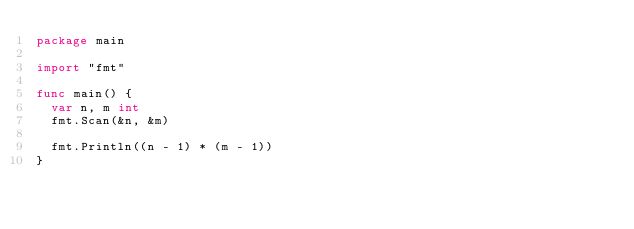<code> <loc_0><loc_0><loc_500><loc_500><_Go_>package main

import "fmt"

func main() {
	var n, m int
	fmt.Scan(&n, &m)

	fmt.Println((n - 1) * (m - 1))
}
</code> 